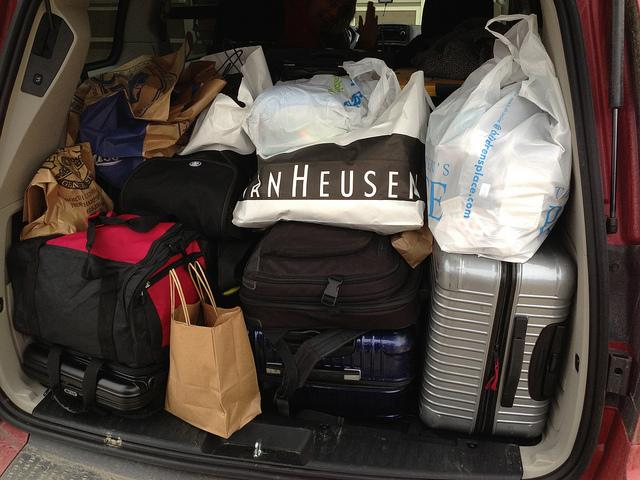What most likely happened before this? packing 